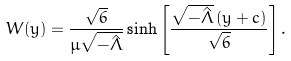Convert formula to latex. <formula><loc_0><loc_0><loc_500><loc_500>W ( y ) = \frac { \sqrt { 6 } } { \mu \sqrt { - \hat { \Lambda } } } \sinh \left [ \frac { \sqrt { - \hat { \Lambda } } \, ( y + c ) } { \sqrt { 6 } } \right ] .</formula> 